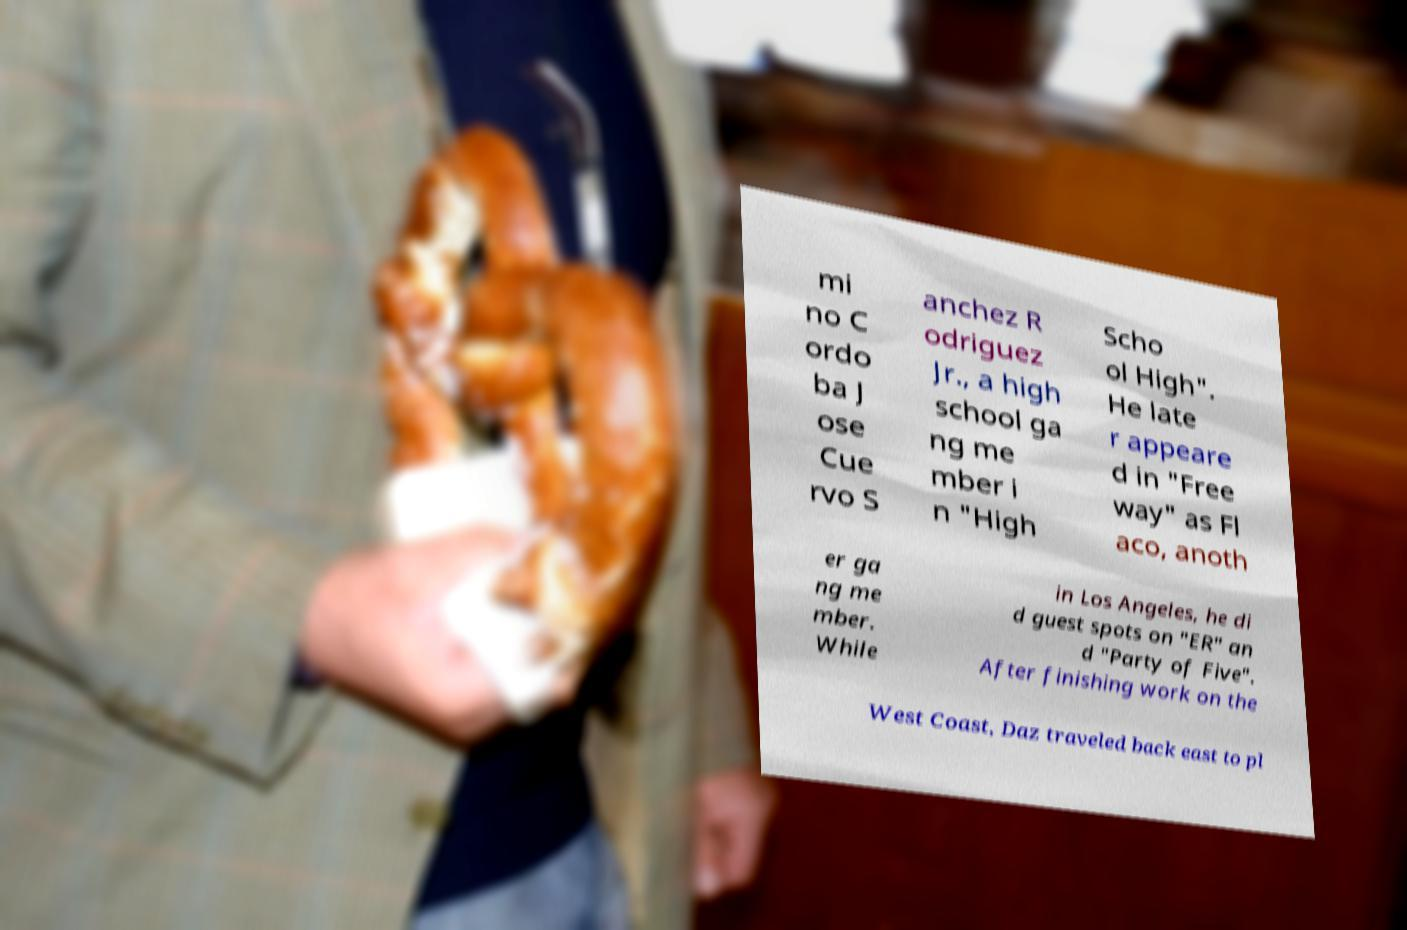For documentation purposes, I need the text within this image transcribed. Could you provide that? mi no C ordo ba J ose Cue rvo S anchez R odriguez Jr., a high school ga ng me mber i n "High Scho ol High". He late r appeare d in "Free way" as Fl aco, anoth er ga ng me mber. While in Los Angeles, he di d guest spots on "ER" an d "Party of Five". After finishing work on the West Coast, Daz traveled back east to pl 